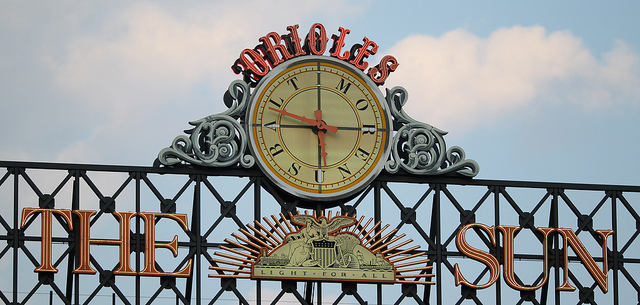Read all the text in this image. ORIOLES M R E N SUN THE ALL FOR LIGHT 0 V B S U L T 